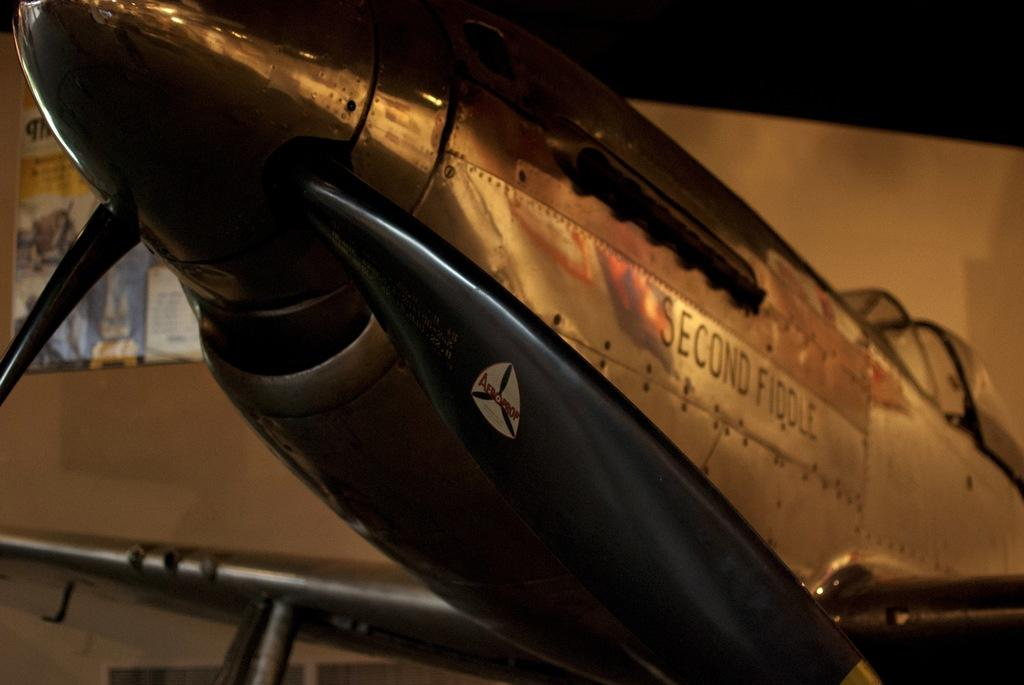<image>
Give a short and clear explanation of the subsequent image. An airplane named Second Fiddle sits in a dimly lit room. 